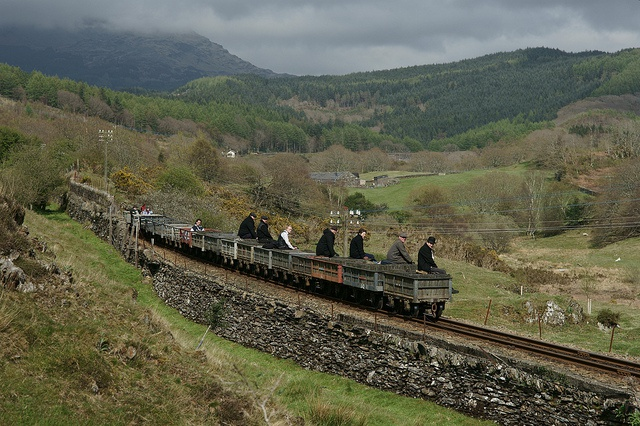Describe the objects in this image and their specific colors. I can see train in gray, black, and darkgreen tones, people in gray, black, darkgreen, and olive tones, people in gray and black tones, people in gray, black, and darkgreen tones, and people in gray, black, and olive tones in this image. 